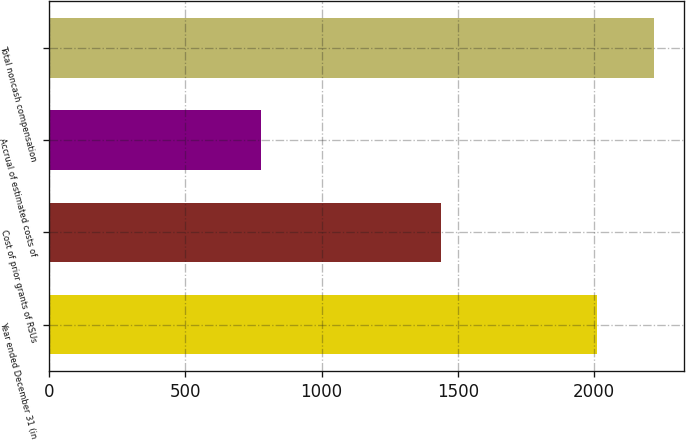<chart> <loc_0><loc_0><loc_500><loc_500><bar_chart><fcel>Year ended December 31 (in<fcel>Cost of prior grants of RSUs<fcel>Accrual of estimated costs of<fcel>Total noncash compensation<nl><fcel>2013<fcel>1440<fcel>779<fcel>2219<nl></chart> 